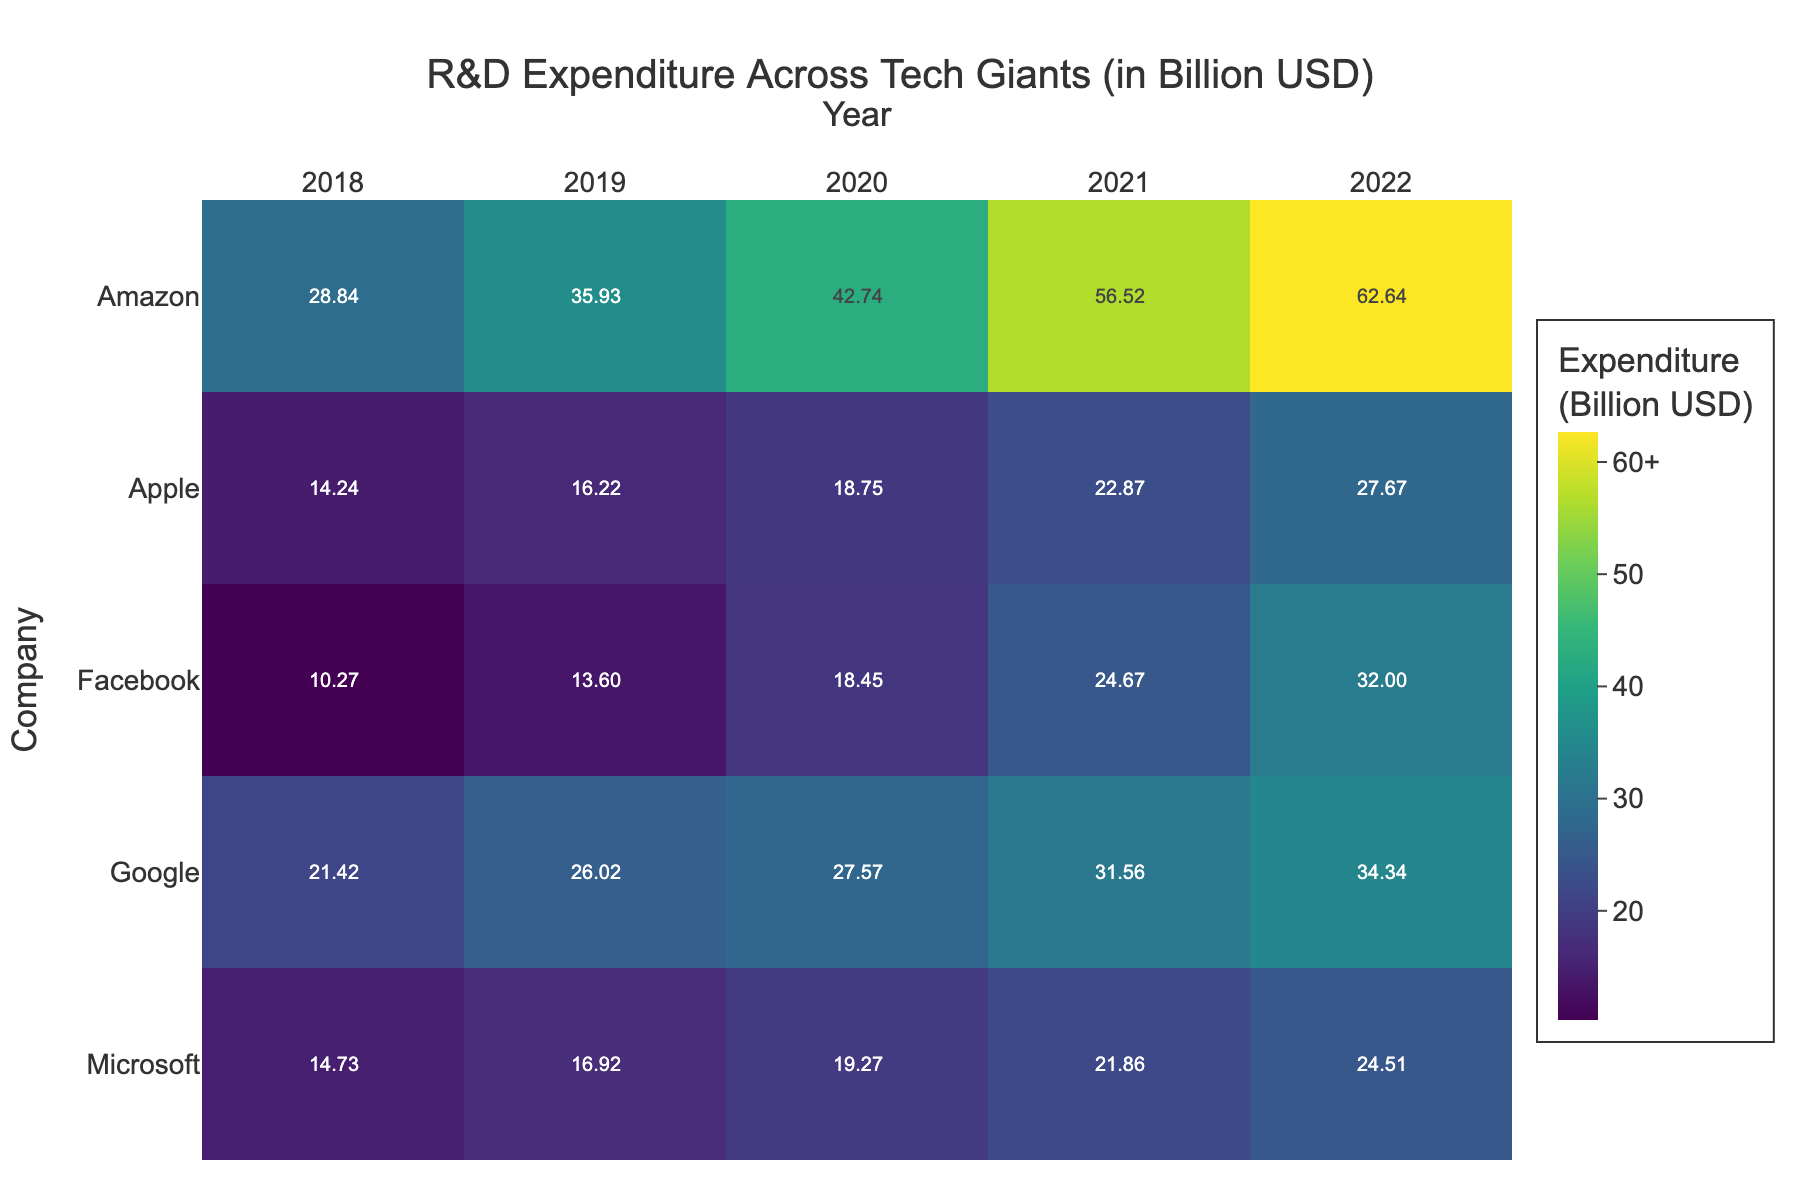what is the title of the figure? The title of the figure is usually at the top. By looking at the text in this position, we can see the title described in the 'title' attribute.
Answer: R&D Expenditure Across Tech Giants (in Billion USD) Which company had the highest R&D expenditure in 2020? Look at the row for each company under the column for the year 2020. The highest value in this column represents the company with the highest expenditure.
Answer: Amazon How much did Apple's R&D expenditure increase from 2018 to 2022? Find Apple's expenditure for the years 2018 and 2022 in the Apple row. Subtract the 2018 value (14.24) from the 2022 value (27.67).
Answer: 13.43 billion USD Which company's R&D expenditure has shown a consistent increase year over year? Look for the company whose row values increase sequentially for each year from 2018 to 2022. Every tech giant in the data has shown consistent yearly growth, so multiple correct answers are possible.
Answer: Apple, Microsoft, Google, Amazon, and Facebook What was the total R&D expenditure of Google from 2018 to 2022? Add up Google's expenditure values for all the years listed: (21.42 + 26.02 + 27.57 + 31.56 + 34.34).
Answer: 140.91 billion USD Which year had the highest overall R&D expenditure among all the companies? Sum up the expenditures for all companies for each year and identify the year with the maximum sum.
Answer: 2022 Compare Amazon and Microsoft's R&D expenditure in 2021. Which one spent more, and by how much? Look at the 2021 values for both Amazon and Microsoft. Subtract Microsoft's expenditure (21.86) from Amazon's expenditure (56.52).
Answer: Amazon, by 34.66 billion USD Which company had the smallest R&D expenditure in 2019? Check the value in the 2019 column for each company. The smallest value in this column indicates the company with the least expenditure.
Answer: Facebook How did Facebook's R&D expenditure in 2020 compare to its expenditure in 2018? Look at Facebook's values for 2020 (18.45) and 2018 (10.27). Subtract the 2018 value from the 2020 value.
Answer: Increased by 8.18 billion USD Which company had the greater increase in R&D expenditure from 2019 to 2022: Google or Microsoft? Calculate the difference between 2019 and 2022 expenditures for both companies (Google: 34.34 - 26.02, Microsoft: 24.51 - 16.92). Compare the two differences.
Answer: Google, 8.32 billion USD 